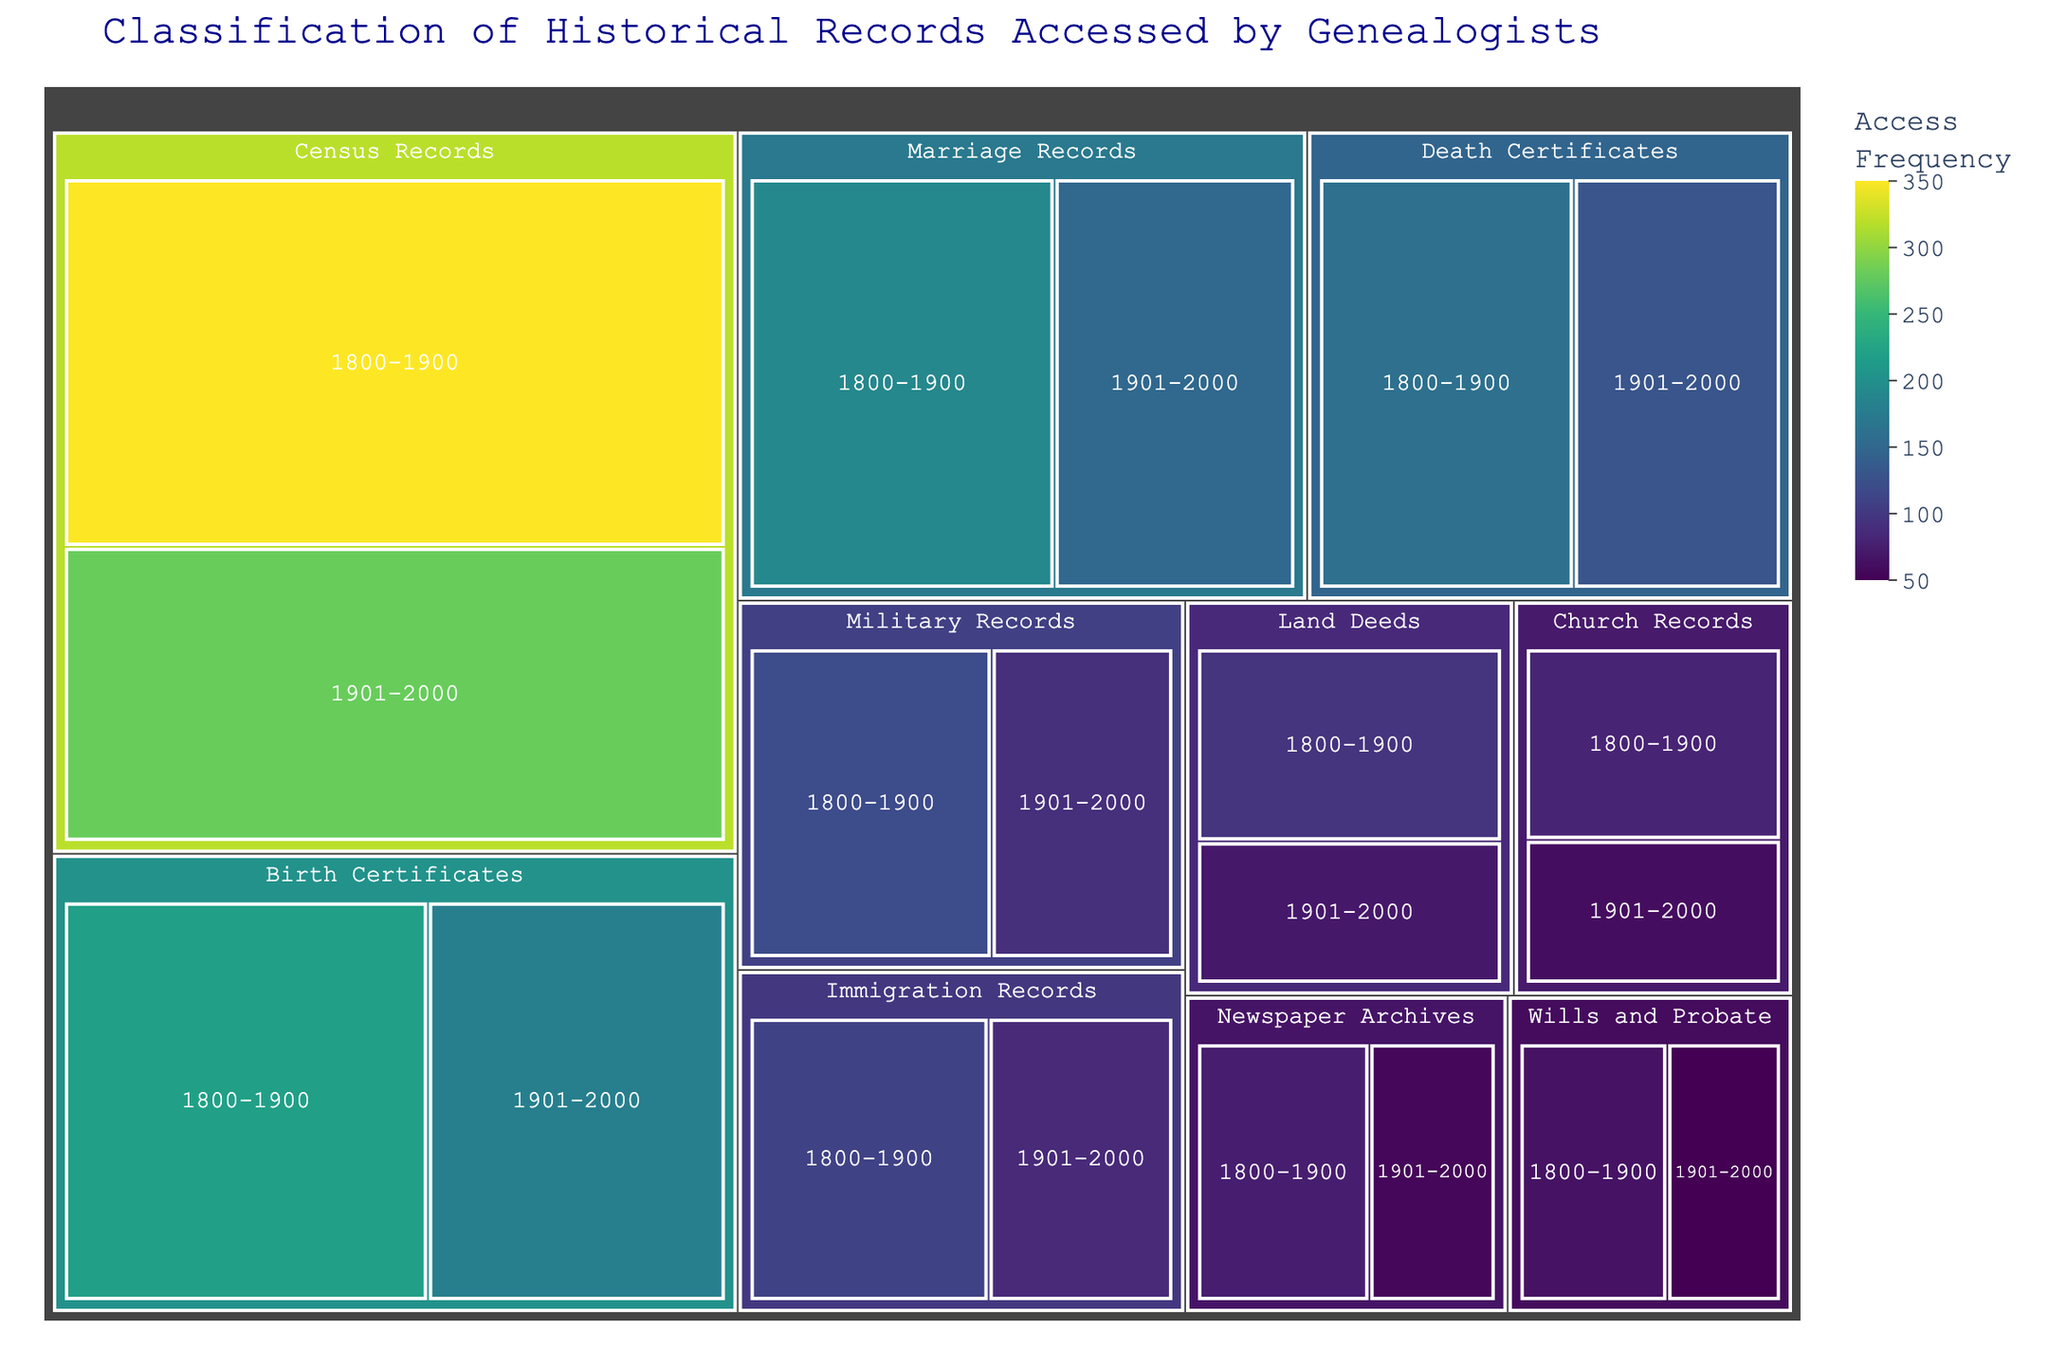What is the title of the treemap figure? The title of the treemap is displayed prominently at the top of the figure. By looking at it, you can easily identify the title.
Answer: Classification of Historical Records Accessed by Genealogists Which record type in the 1800-1900 time period has the highest access frequency? Examine the figure and look for the largest segment under the 1800-1900 time period. The largest segment representing the most accessed record type is Census Records.
Answer: Census Records How does the access frequency of Birth Certificates from 1800-1900 compare to that from 1901-2000? Locate both segments representing Birth Certificates for the two time periods. Compare their sizes or refer to the numerical value shown. The segment for 1800-1900 is larger than that for 1901-2000.
Answer: 1800-1900 has a higher frequency What is the combined access frequency of all record types in the 1800-1900 period? Sum the access frequencies of all record types listed under the 1800-1900 category. The values are 350 + 220 + 190 + 160 + 120 + 110 + 95 + 80 + 75 + 65 = 1465.
Answer: 1465 Which time period has more access frequency for Military Records? Identify and compare the access frequencies for Military Records in both periods. The 1800-1900 segment for Military Records is larger than the 1901-2000 segment.
Answer: 1800-1900 What is the difference in access frequency between Census Records and Immigration Records in the 1901-2000 period? Find the access frequencies for both Census Records and Immigration Records in the 1901-2000 period and subtract the smaller value from the larger one. The calculation is 280 - 85 = 195.
Answer: 195 Which three record types in the 1800-1900 period have the lowest access frequencies? Look for the smallest segments under the 1800-1900 period and identify the three record types with the lowest access frequencies. They are Wills and Probate, Newspaper Archives, and Church Records.
Answer: Wills and Probate, Newspaper Archives, Church Records In which period do Newspaper Archives have more access frequency? Compare the size of the segments or the numerical values for Newspaper Archives in both time periods. The segment for 1800-1900 is larger than that for 1901-2000.
Answer: 1800-1900 What is the ratio of access frequency for Death Certificates between the two periods? Find the access frequencies for Death Certificates in both periods and divide the value for 1800-1900 by the value for 1901-2000. The calculation is 160 / 130 ≈ 1.23.
Answer: ~1.23 